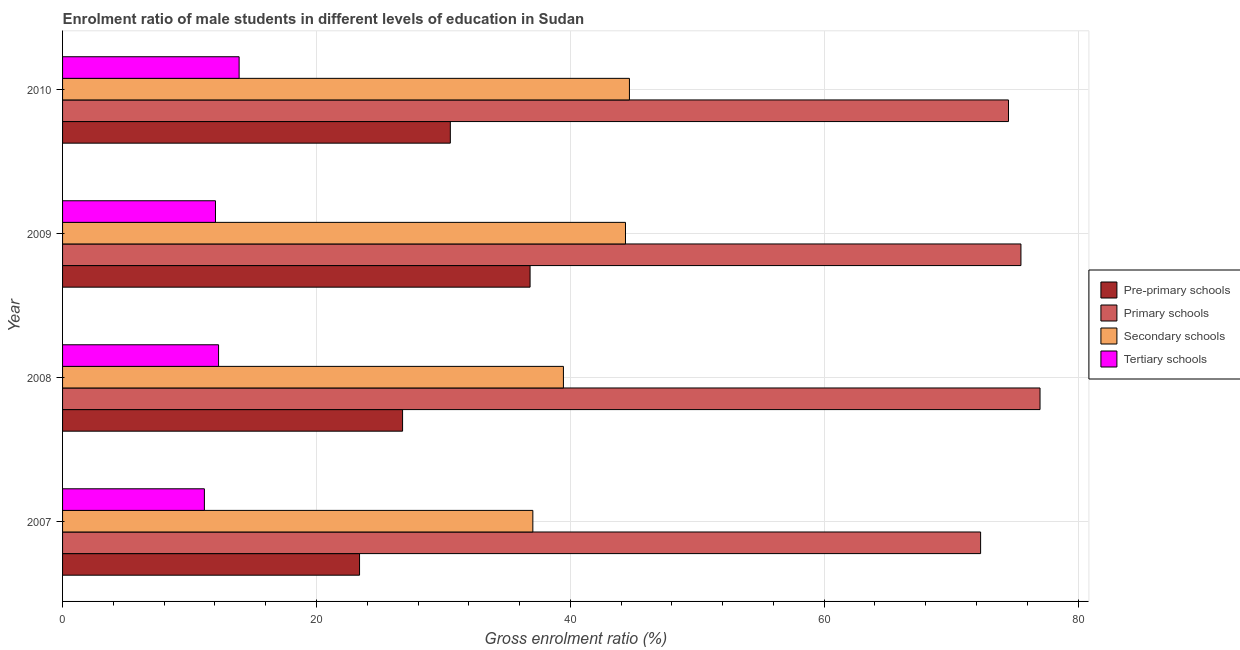How many different coloured bars are there?
Make the answer very short. 4. Are the number of bars on each tick of the Y-axis equal?
Give a very brief answer. Yes. How many bars are there on the 3rd tick from the top?
Provide a short and direct response. 4. What is the label of the 1st group of bars from the top?
Provide a short and direct response. 2010. In how many cases, is the number of bars for a given year not equal to the number of legend labels?
Keep it short and to the point. 0. What is the gross enrolment ratio(female) in primary schools in 2007?
Provide a succinct answer. 72.32. Across all years, what is the maximum gross enrolment ratio(female) in tertiary schools?
Your response must be concise. 13.91. Across all years, what is the minimum gross enrolment ratio(female) in secondary schools?
Offer a terse response. 37.05. In which year was the gross enrolment ratio(female) in primary schools minimum?
Offer a very short reply. 2007. What is the total gross enrolment ratio(female) in pre-primary schools in the graph?
Your answer should be compact. 117.56. What is the difference between the gross enrolment ratio(female) in tertiary schools in 2008 and that in 2010?
Offer a very short reply. -1.62. What is the difference between the gross enrolment ratio(female) in secondary schools in 2010 and the gross enrolment ratio(female) in pre-primary schools in 2008?
Provide a succinct answer. 17.87. What is the average gross enrolment ratio(female) in primary schools per year?
Offer a terse response. 74.83. In the year 2008, what is the difference between the gross enrolment ratio(female) in pre-primary schools and gross enrolment ratio(female) in secondary schools?
Your answer should be very brief. -12.67. In how many years, is the gross enrolment ratio(female) in tertiary schools greater than 40 %?
Your answer should be very brief. 0. What is the ratio of the gross enrolment ratio(female) in secondary schools in 2007 to that in 2010?
Your answer should be very brief. 0.83. Is the difference between the gross enrolment ratio(female) in secondary schools in 2008 and 2010 greater than the difference between the gross enrolment ratio(female) in tertiary schools in 2008 and 2010?
Offer a terse response. No. What is the difference between the highest and the second highest gross enrolment ratio(female) in primary schools?
Offer a very short reply. 1.5. What is the difference between the highest and the lowest gross enrolment ratio(female) in pre-primary schools?
Make the answer very short. 13.43. What does the 4th bar from the top in 2009 represents?
Ensure brevity in your answer.  Pre-primary schools. What does the 3rd bar from the bottom in 2010 represents?
Ensure brevity in your answer.  Secondary schools. Is it the case that in every year, the sum of the gross enrolment ratio(female) in pre-primary schools and gross enrolment ratio(female) in primary schools is greater than the gross enrolment ratio(female) in secondary schools?
Provide a short and direct response. Yes. How many bars are there?
Offer a very short reply. 16. What is the difference between two consecutive major ticks on the X-axis?
Offer a terse response. 20. Does the graph contain any zero values?
Keep it short and to the point. No. Does the graph contain grids?
Keep it short and to the point. Yes. How are the legend labels stacked?
Your answer should be very brief. Vertical. What is the title of the graph?
Give a very brief answer. Enrolment ratio of male students in different levels of education in Sudan. What is the Gross enrolment ratio (%) of Pre-primary schools in 2007?
Keep it short and to the point. 23.4. What is the Gross enrolment ratio (%) in Primary schools in 2007?
Your answer should be compact. 72.32. What is the Gross enrolment ratio (%) in Secondary schools in 2007?
Ensure brevity in your answer.  37.05. What is the Gross enrolment ratio (%) in Tertiary schools in 2007?
Provide a succinct answer. 11.17. What is the Gross enrolment ratio (%) in Pre-primary schools in 2008?
Ensure brevity in your answer.  26.79. What is the Gross enrolment ratio (%) in Primary schools in 2008?
Your answer should be compact. 77. What is the Gross enrolment ratio (%) in Secondary schools in 2008?
Offer a very short reply. 39.46. What is the Gross enrolment ratio (%) in Tertiary schools in 2008?
Provide a succinct answer. 12.29. What is the Gross enrolment ratio (%) of Pre-primary schools in 2009?
Ensure brevity in your answer.  36.83. What is the Gross enrolment ratio (%) of Primary schools in 2009?
Ensure brevity in your answer.  75.5. What is the Gross enrolment ratio (%) of Secondary schools in 2009?
Your answer should be compact. 44.35. What is the Gross enrolment ratio (%) of Tertiary schools in 2009?
Offer a terse response. 12.05. What is the Gross enrolment ratio (%) in Pre-primary schools in 2010?
Provide a short and direct response. 30.55. What is the Gross enrolment ratio (%) of Primary schools in 2010?
Offer a terse response. 74.52. What is the Gross enrolment ratio (%) of Secondary schools in 2010?
Offer a very short reply. 44.66. What is the Gross enrolment ratio (%) of Tertiary schools in 2010?
Offer a terse response. 13.91. Across all years, what is the maximum Gross enrolment ratio (%) in Pre-primary schools?
Give a very brief answer. 36.83. Across all years, what is the maximum Gross enrolment ratio (%) of Primary schools?
Provide a succinct answer. 77. Across all years, what is the maximum Gross enrolment ratio (%) of Secondary schools?
Ensure brevity in your answer.  44.66. Across all years, what is the maximum Gross enrolment ratio (%) in Tertiary schools?
Your answer should be very brief. 13.91. Across all years, what is the minimum Gross enrolment ratio (%) of Pre-primary schools?
Make the answer very short. 23.4. Across all years, what is the minimum Gross enrolment ratio (%) in Primary schools?
Provide a succinct answer. 72.32. Across all years, what is the minimum Gross enrolment ratio (%) of Secondary schools?
Make the answer very short. 37.05. Across all years, what is the minimum Gross enrolment ratio (%) of Tertiary schools?
Your response must be concise. 11.17. What is the total Gross enrolment ratio (%) in Pre-primary schools in the graph?
Provide a succinct answer. 117.56. What is the total Gross enrolment ratio (%) in Primary schools in the graph?
Make the answer very short. 299.34. What is the total Gross enrolment ratio (%) in Secondary schools in the graph?
Your answer should be compact. 165.5. What is the total Gross enrolment ratio (%) of Tertiary schools in the graph?
Offer a terse response. 49.42. What is the difference between the Gross enrolment ratio (%) of Pre-primary schools in 2007 and that in 2008?
Your response must be concise. -3.39. What is the difference between the Gross enrolment ratio (%) of Primary schools in 2007 and that in 2008?
Your answer should be compact. -4.68. What is the difference between the Gross enrolment ratio (%) in Secondary schools in 2007 and that in 2008?
Offer a very short reply. -2.41. What is the difference between the Gross enrolment ratio (%) in Tertiary schools in 2007 and that in 2008?
Offer a very short reply. -1.12. What is the difference between the Gross enrolment ratio (%) in Pre-primary schools in 2007 and that in 2009?
Keep it short and to the point. -13.43. What is the difference between the Gross enrolment ratio (%) of Primary schools in 2007 and that in 2009?
Make the answer very short. -3.18. What is the difference between the Gross enrolment ratio (%) in Secondary schools in 2007 and that in 2009?
Give a very brief answer. -7.3. What is the difference between the Gross enrolment ratio (%) of Tertiary schools in 2007 and that in 2009?
Offer a terse response. -0.87. What is the difference between the Gross enrolment ratio (%) in Pre-primary schools in 2007 and that in 2010?
Offer a terse response. -7.15. What is the difference between the Gross enrolment ratio (%) in Primary schools in 2007 and that in 2010?
Offer a terse response. -2.2. What is the difference between the Gross enrolment ratio (%) in Secondary schools in 2007 and that in 2010?
Make the answer very short. -7.61. What is the difference between the Gross enrolment ratio (%) in Tertiary schools in 2007 and that in 2010?
Your response must be concise. -2.74. What is the difference between the Gross enrolment ratio (%) in Pre-primary schools in 2008 and that in 2009?
Your response must be concise. -10.04. What is the difference between the Gross enrolment ratio (%) of Primary schools in 2008 and that in 2009?
Make the answer very short. 1.5. What is the difference between the Gross enrolment ratio (%) of Secondary schools in 2008 and that in 2009?
Provide a succinct answer. -4.89. What is the difference between the Gross enrolment ratio (%) of Tertiary schools in 2008 and that in 2009?
Provide a short and direct response. 0.24. What is the difference between the Gross enrolment ratio (%) in Pre-primary schools in 2008 and that in 2010?
Provide a succinct answer. -3.76. What is the difference between the Gross enrolment ratio (%) in Primary schools in 2008 and that in 2010?
Provide a short and direct response. 2.48. What is the difference between the Gross enrolment ratio (%) in Secondary schools in 2008 and that in 2010?
Your answer should be very brief. -5.2. What is the difference between the Gross enrolment ratio (%) of Tertiary schools in 2008 and that in 2010?
Make the answer very short. -1.62. What is the difference between the Gross enrolment ratio (%) in Pre-primary schools in 2009 and that in 2010?
Give a very brief answer. 6.28. What is the difference between the Gross enrolment ratio (%) of Secondary schools in 2009 and that in 2010?
Keep it short and to the point. -0.31. What is the difference between the Gross enrolment ratio (%) in Tertiary schools in 2009 and that in 2010?
Your answer should be very brief. -1.86. What is the difference between the Gross enrolment ratio (%) of Pre-primary schools in 2007 and the Gross enrolment ratio (%) of Primary schools in 2008?
Your answer should be very brief. -53.61. What is the difference between the Gross enrolment ratio (%) in Pre-primary schools in 2007 and the Gross enrolment ratio (%) in Secondary schools in 2008?
Your answer should be very brief. -16.06. What is the difference between the Gross enrolment ratio (%) of Pre-primary schools in 2007 and the Gross enrolment ratio (%) of Tertiary schools in 2008?
Provide a succinct answer. 11.11. What is the difference between the Gross enrolment ratio (%) of Primary schools in 2007 and the Gross enrolment ratio (%) of Secondary schools in 2008?
Provide a short and direct response. 32.86. What is the difference between the Gross enrolment ratio (%) in Primary schools in 2007 and the Gross enrolment ratio (%) in Tertiary schools in 2008?
Make the answer very short. 60.03. What is the difference between the Gross enrolment ratio (%) of Secondary schools in 2007 and the Gross enrolment ratio (%) of Tertiary schools in 2008?
Provide a short and direct response. 24.76. What is the difference between the Gross enrolment ratio (%) in Pre-primary schools in 2007 and the Gross enrolment ratio (%) in Primary schools in 2009?
Make the answer very short. -52.1. What is the difference between the Gross enrolment ratio (%) of Pre-primary schools in 2007 and the Gross enrolment ratio (%) of Secondary schools in 2009?
Provide a succinct answer. -20.95. What is the difference between the Gross enrolment ratio (%) in Pre-primary schools in 2007 and the Gross enrolment ratio (%) in Tertiary schools in 2009?
Your answer should be compact. 11.35. What is the difference between the Gross enrolment ratio (%) of Primary schools in 2007 and the Gross enrolment ratio (%) of Secondary schools in 2009?
Keep it short and to the point. 27.98. What is the difference between the Gross enrolment ratio (%) in Primary schools in 2007 and the Gross enrolment ratio (%) in Tertiary schools in 2009?
Keep it short and to the point. 60.27. What is the difference between the Gross enrolment ratio (%) of Secondary schools in 2007 and the Gross enrolment ratio (%) of Tertiary schools in 2009?
Your answer should be compact. 25. What is the difference between the Gross enrolment ratio (%) in Pre-primary schools in 2007 and the Gross enrolment ratio (%) in Primary schools in 2010?
Ensure brevity in your answer.  -51.12. What is the difference between the Gross enrolment ratio (%) of Pre-primary schools in 2007 and the Gross enrolment ratio (%) of Secondary schools in 2010?
Your answer should be very brief. -21.26. What is the difference between the Gross enrolment ratio (%) of Pre-primary schools in 2007 and the Gross enrolment ratio (%) of Tertiary schools in 2010?
Make the answer very short. 9.49. What is the difference between the Gross enrolment ratio (%) in Primary schools in 2007 and the Gross enrolment ratio (%) in Secondary schools in 2010?
Give a very brief answer. 27.66. What is the difference between the Gross enrolment ratio (%) in Primary schools in 2007 and the Gross enrolment ratio (%) in Tertiary schools in 2010?
Provide a short and direct response. 58.41. What is the difference between the Gross enrolment ratio (%) of Secondary schools in 2007 and the Gross enrolment ratio (%) of Tertiary schools in 2010?
Provide a short and direct response. 23.14. What is the difference between the Gross enrolment ratio (%) of Pre-primary schools in 2008 and the Gross enrolment ratio (%) of Primary schools in 2009?
Ensure brevity in your answer.  -48.71. What is the difference between the Gross enrolment ratio (%) of Pre-primary schools in 2008 and the Gross enrolment ratio (%) of Secondary schools in 2009?
Your response must be concise. -17.56. What is the difference between the Gross enrolment ratio (%) of Pre-primary schools in 2008 and the Gross enrolment ratio (%) of Tertiary schools in 2009?
Ensure brevity in your answer.  14.74. What is the difference between the Gross enrolment ratio (%) of Primary schools in 2008 and the Gross enrolment ratio (%) of Secondary schools in 2009?
Your answer should be very brief. 32.66. What is the difference between the Gross enrolment ratio (%) in Primary schools in 2008 and the Gross enrolment ratio (%) in Tertiary schools in 2009?
Your answer should be compact. 64.96. What is the difference between the Gross enrolment ratio (%) of Secondary schools in 2008 and the Gross enrolment ratio (%) of Tertiary schools in 2009?
Provide a short and direct response. 27.41. What is the difference between the Gross enrolment ratio (%) of Pre-primary schools in 2008 and the Gross enrolment ratio (%) of Primary schools in 2010?
Keep it short and to the point. -47.73. What is the difference between the Gross enrolment ratio (%) of Pre-primary schools in 2008 and the Gross enrolment ratio (%) of Secondary schools in 2010?
Offer a terse response. -17.87. What is the difference between the Gross enrolment ratio (%) in Pre-primary schools in 2008 and the Gross enrolment ratio (%) in Tertiary schools in 2010?
Your answer should be compact. 12.88. What is the difference between the Gross enrolment ratio (%) of Primary schools in 2008 and the Gross enrolment ratio (%) of Secondary schools in 2010?
Offer a terse response. 32.34. What is the difference between the Gross enrolment ratio (%) in Primary schools in 2008 and the Gross enrolment ratio (%) in Tertiary schools in 2010?
Offer a very short reply. 63.09. What is the difference between the Gross enrolment ratio (%) in Secondary schools in 2008 and the Gross enrolment ratio (%) in Tertiary schools in 2010?
Ensure brevity in your answer.  25.55. What is the difference between the Gross enrolment ratio (%) in Pre-primary schools in 2009 and the Gross enrolment ratio (%) in Primary schools in 2010?
Your answer should be very brief. -37.69. What is the difference between the Gross enrolment ratio (%) in Pre-primary schools in 2009 and the Gross enrolment ratio (%) in Secondary schools in 2010?
Offer a terse response. -7.83. What is the difference between the Gross enrolment ratio (%) of Pre-primary schools in 2009 and the Gross enrolment ratio (%) of Tertiary schools in 2010?
Keep it short and to the point. 22.92. What is the difference between the Gross enrolment ratio (%) in Primary schools in 2009 and the Gross enrolment ratio (%) in Secondary schools in 2010?
Provide a short and direct response. 30.84. What is the difference between the Gross enrolment ratio (%) in Primary schools in 2009 and the Gross enrolment ratio (%) in Tertiary schools in 2010?
Offer a terse response. 61.59. What is the difference between the Gross enrolment ratio (%) of Secondary schools in 2009 and the Gross enrolment ratio (%) of Tertiary schools in 2010?
Keep it short and to the point. 30.44. What is the average Gross enrolment ratio (%) in Pre-primary schools per year?
Give a very brief answer. 29.39. What is the average Gross enrolment ratio (%) of Primary schools per year?
Offer a very short reply. 74.83. What is the average Gross enrolment ratio (%) in Secondary schools per year?
Offer a terse response. 41.38. What is the average Gross enrolment ratio (%) of Tertiary schools per year?
Provide a succinct answer. 12.35. In the year 2007, what is the difference between the Gross enrolment ratio (%) of Pre-primary schools and Gross enrolment ratio (%) of Primary schools?
Provide a short and direct response. -48.93. In the year 2007, what is the difference between the Gross enrolment ratio (%) of Pre-primary schools and Gross enrolment ratio (%) of Secondary schools?
Ensure brevity in your answer.  -13.65. In the year 2007, what is the difference between the Gross enrolment ratio (%) in Pre-primary schools and Gross enrolment ratio (%) in Tertiary schools?
Provide a succinct answer. 12.22. In the year 2007, what is the difference between the Gross enrolment ratio (%) in Primary schools and Gross enrolment ratio (%) in Secondary schools?
Your answer should be compact. 35.27. In the year 2007, what is the difference between the Gross enrolment ratio (%) in Primary schools and Gross enrolment ratio (%) in Tertiary schools?
Provide a short and direct response. 61.15. In the year 2007, what is the difference between the Gross enrolment ratio (%) of Secondary schools and Gross enrolment ratio (%) of Tertiary schools?
Offer a terse response. 25.87. In the year 2008, what is the difference between the Gross enrolment ratio (%) in Pre-primary schools and Gross enrolment ratio (%) in Primary schools?
Ensure brevity in your answer.  -50.22. In the year 2008, what is the difference between the Gross enrolment ratio (%) in Pre-primary schools and Gross enrolment ratio (%) in Secondary schools?
Make the answer very short. -12.67. In the year 2008, what is the difference between the Gross enrolment ratio (%) in Pre-primary schools and Gross enrolment ratio (%) in Tertiary schools?
Ensure brevity in your answer.  14.5. In the year 2008, what is the difference between the Gross enrolment ratio (%) in Primary schools and Gross enrolment ratio (%) in Secondary schools?
Provide a succinct answer. 37.55. In the year 2008, what is the difference between the Gross enrolment ratio (%) of Primary schools and Gross enrolment ratio (%) of Tertiary schools?
Offer a very short reply. 64.71. In the year 2008, what is the difference between the Gross enrolment ratio (%) in Secondary schools and Gross enrolment ratio (%) in Tertiary schools?
Provide a short and direct response. 27.17. In the year 2009, what is the difference between the Gross enrolment ratio (%) in Pre-primary schools and Gross enrolment ratio (%) in Primary schools?
Provide a short and direct response. -38.67. In the year 2009, what is the difference between the Gross enrolment ratio (%) in Pre-primary schools and Gross enrolment ratio (%) in Secondary schools?
Your response must be concise. -7.52. In the year 2009, what is the difference between the Gross enrolment ratio (%) in Pre-primary schools and Gross enrolment ratio (%) in Tertiary schools?
Offer a very short reply. 24.78. In the year 2009, what is the difference between the Gross enrolment ratio (%) in Primary schools and Gross enrolment ratio (%) in Secondary schools?
Make the answer very short. 31.15. In the year 2009, what is the difference between the Gross enrolment ratio (%) in Primary schools and Gross enrolment ratio (%) in Tertiary schools?
Give a very brief answer. 63.45. In the year 2009, what is the difference between the Gross enrolment ratio (%) of Secondary schools and Gross enrolment ratio (%) of Tertiary schools?
Give a very brief answer. 32.3. In the year 2010, what is the difference between the Gross enrolment ratio (%) of Pre-primary schools and Gross enrolment ratio (%) of Primary schools?
Provide a short and direct response. -43.97. In the year 2010, what is the difference between the Gross enrolment ratio (%) in Pre-primary schools and Gross enrolment ratio (%) in Secondary schools?
Give a very brief answer. -14.11. In the year 2010, what is the difference between the Gross enrolment ratio (%) in Pre-primary schools and Gross enrolment ratio (%) in Tertiary schools?
Keep it short and to the point. 16.64. In the year 2010, what is the difference between the Gross enrolment ratio (%) of Primary schools and Gross enrolment ratio (%) of Secondary schools?
Give a very brief answer. 29.86. In the year 2010, what is the difference between the Gross enrolment ratio (%) of Primary schools and Gross enrolment ratio (%) of Tertiary schools?
Your answer should be compact. 60.61. In the year 2010, what is the difference between the Gross enrolment ratio (%) of Secondary schools and Gross enrolment ratio (%) of Tertiary schools?
Offer a terse response. 30.75. What is the ratio of the Gross enrolment ratio (%) of Pre-primary schools in 2007 to that in 2008?
Your answer should be compact. 0.87. What is the ratio of the Gross enrolment ratio (%) in Primary schools in 2007 to that in 2008?
Your response must be concise. 0.94. What is the ratio of the Gross enrolment ratio (%) in Secondary schools in 2007 to that in 2008?
Provide a succinct answer. 0.94. What is the ratio of the Gross enrolment ratio (%) of Pre-primary schools in 2007 to that in 2009?
Offer a very short reply. 0.64. What is the ratio of the Gross enrolment ratio (%) in Primary schools in 2007 to that in 2009?
Offer a very short reply. 0.96. What is the ratio of the Gross enrolment ratio (%) of Secondary schools in 2007 to that in 2009?
Provide a succinct answer. 0.84. What is the ratio of the Gross enrolment ratio (%) in Tertiary schools in 2007 to that in 2009?
Offer a very short reply. 0.93. What is the ratio of the Gross enrolment ratio (%) in Pre-primary schools in 2007 to that in 2010?
Offer a very short reply. 0.77. What is the ratio of the Gross enrolment ratio (%) of Primary schools in 2007 to that in 2010?
Offer a very short reply. 0.97. What is the ratio of the Gross enrolment ratio (%) of Secondary schools in 2007 to that in 2010?
Ensure brevity in your answer.  0.83. What is the ratio of the Gross enrolment ratio (%) of Tertiary schools in 2007 to that in 2010?
Provide a short and direct response. 0.8. What is the ratio of the Gross enrolment ratio (%) in Pre-primary schools in 2008 to that in 2009?
Ensure brevity in your answer.  0.73. What is the ratio of the Gross enrolment ratio (%) of Primary schools in 2008 to that in 2009?
Ensure brevity in your answer.  1.02. What is the ratio of the Gross enrolment ratio (%) in Secondary schools in 2008 to that in 2009?
Keep it short and to the point. 0.89. What is the ratio of the Gross enrolment ratio (%) of Tertiary schools in 2008 to that in 2009?
Offer a very short reply. 1.02. What is the ratio of the Gross enrolment ratio (%) of Pre-primary schools in 2008 to that in 2010?
Make the answer very short. 0.88. What is the ratio of the Gross enrolment ratio (%) of Primary schools in 2008 to that in 2010?
Offer a very short reply. 1.03. What is the ratio of the Gross enrolment ratio (%) in Secondary schools in 2008 to that in 2010?
Provide a short and direct response. 0.88. What is the ratio of the Gross enrolment ratio (%) of Tertiary schools in 2008 to that in 2010?
Offer a terse response. 0.88. What is the ratio of the Gross enrolment ratio (%) of Pre-primary schools in 2009 to that in 2010?
Your answer should be compact. 1.21. What is the ratio of the Gross enrolment ratio (%) of Primary schools in 2009 to that in 2010?
Your answer should be very brief. 1.01. What is the ratio of the Gross enrolment ratio (%) in Secondary schools in 2009 to that in 2010?
Provide a short and direct response. 0.99. What is the ratio of the Gross enrolment ratio (%) of Tertiary schools in 2009 to that in 2010?
Ensure brevity in your answer.  0.87. What is the difference between the highest and the second highest Gross enrolment ratio (%) in Pre-primary schools?
Offer a very short reply. 6.28. What is the difference between the highest and the second highest Gross enrolment ratio (%) in Primary schools?
Offer a very short reply. 1.5. What is the difference between the highest and the second highest Gross enrolment ratio (%) of Secondary schools?
Offer a very short reply. 0.31. What is the difference between the highest and the second highest Gross enrolment ratio (%) of Tertiary schools?
Offer a very short reply. 1.62. What is the difference between the highest and the lowest Gross enrolment ratio (%) of Pre-primary schools?
Provide a short and direct response. 13.43. What is the difference between the highest and the lowest Gross enrolment ratio (%) in Primary schools?
Ensure brevity in your answer.  4.68. What is the difference between the highest and the lowest Gross enrolment ratio (%) in Secondary schools?
Keep it short and to the point. 7.61. What is the difference between the highest and the lowest Gross enrolment ratio (%) of Tertiary schools?
Your answer should be compact. 2.74. 